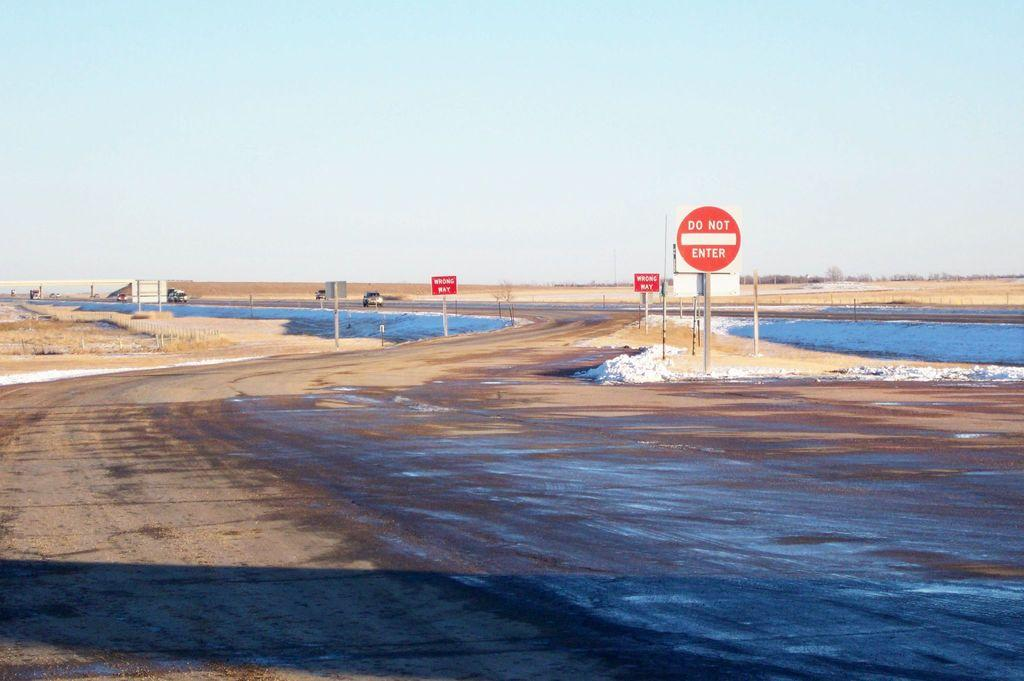Provide a one-sentence caption for the provided image. An area by water has Do Not Enter and wrong ways signs posted. 